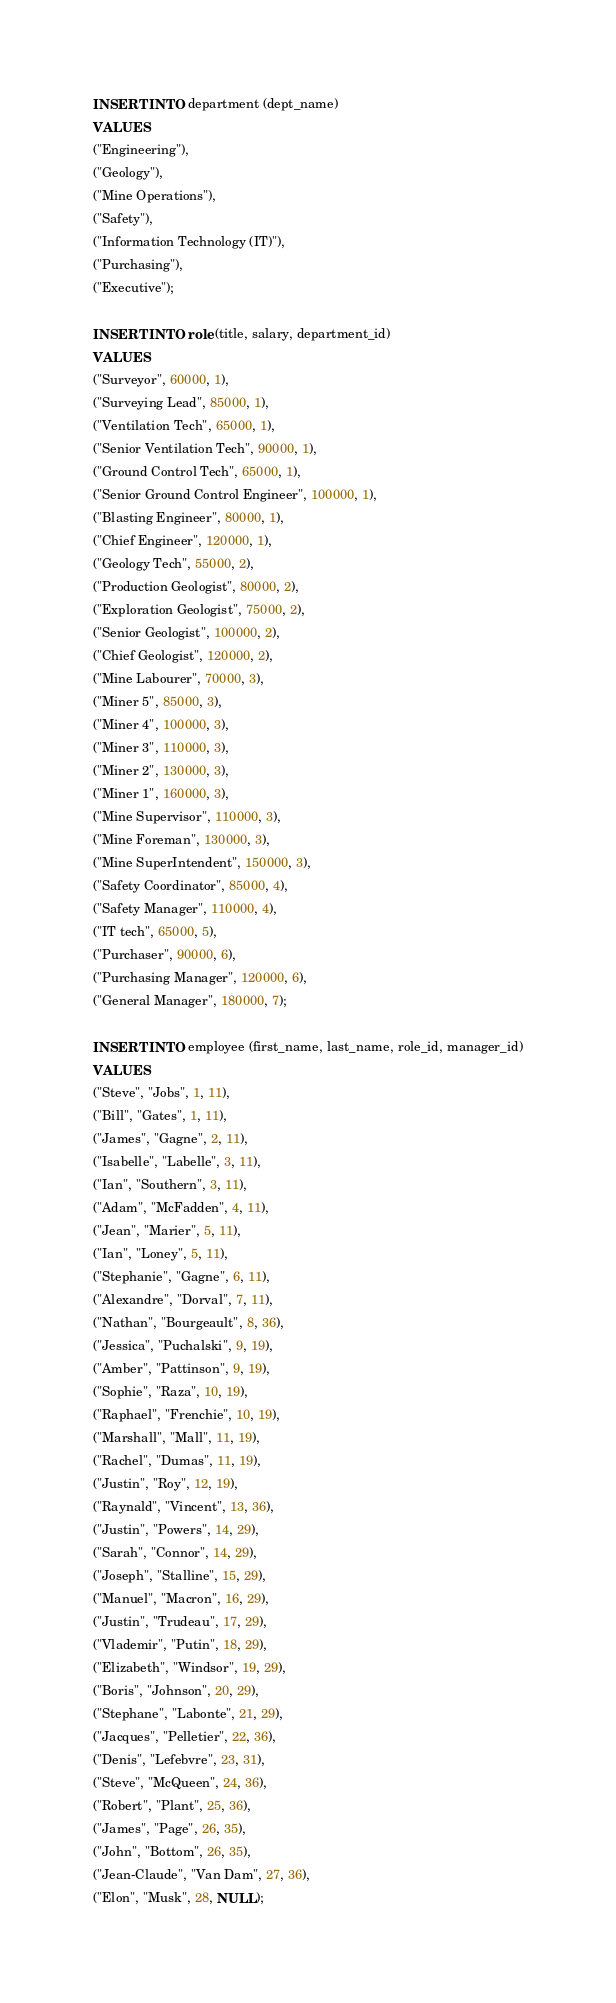<code> <loc_0><loc_0><loc_500><loc_500><_SQL_>INSERT INTO department (dept_name)
VALUES
("Engineering"),
("Geology"),
("Mine Operations"),
("Safety"),
("Information Technology (IT)"),
("Purchasing"),
("Executive");

INSERT INTO role (title, salary, department_id)
VALUES
("Surveyor", 60000, 1),
("Surveying Lead", 85000, 1),
("Ventilation Tech", 65000, 1),
("Senior Ventilation Tech", 90000, 1),
("Ground Control Tech", 65000, 1),
("Senior Ground Control Engineer", 100000, 1),
("Blasting Engineer", 80000, 1),
("Chief Engineer", 120000, 1),
("Geology Tech", 55000, 2),
("Production Geologist", 80000, 2),
("Exploration Geologist", 75000, 2),
("Senior Geologist", 100000, 2),
("Chief Geologist", 120000, 2),
("Mine Labourer", 70000, 3),
("Miner 5", 85000, 3),
("Miner 4", 100000, 3),
("Miner 3", 110000, 3),
("Miner 2", 130000, 3),
("Miner 1", 160000, 3),
("Mine Supervisor", 110000, 3),
("Mine Foreman", 130000, 3),
("Mine SuperIntendent", 150000, 3),
("Safety Coordinator", 85000, 4),
("Safety Manager", 110000, 4),
("IT tech", 65000, 5),
("Purchaser", 90000, 6),
("Purchasing Manager", 120000, 6),
("General Manager", 180000, 7);

INSERT INTO employee (first_name, last_name, role_id, manager_id)
VALUES
("Steve", "Jobs", 1, 11),
("Bill", "Gates", 1, 11),
("James", "Gagne", 2, 11),
("Isabelle", "Labelle", 3, 11),
("Ian", "Southern", 3, 11),
("Adam", "McFadden", 4, 11),
("Jean", "Marier", 5, 11),
("Ian", "Loney", 5, 11),
("Stephanie", "Gagne", 6, 11),
("Alexandre", "Dorval", 7, 11),
("Nathan", "Bourgeault", 8, 36),
("Jessica", "Puchalski", 9, 19),
("Amber", "Pattinson", 9, 19),
("Sophie", "Raza", 10, 19),
("Raphael", "Frenchie", 10, 19),
("Marshall", "Mall", 11, 19),
("Rachel", "Dumas", 11, 19),
("Justin", "Roy", 12, 19),
("Raynald", "Vincent", 13, 36),
("Justin", "Powers", 14, 29),
("Sarah", "Connor", 14, 29),
("Joseph", "Stalline", 15, 29),
("Manuel", "Macron", 16, 29),
("Justin", "Trudeau", 17, 29),
("Vlademir", "Putin", 18, 29),
("Elizabeth", "Windsor", 19, 29),
("Boris", "Johnson", 20, 29),
("Stephane", "Labonte", 21, 29),
("Jacques", "Pelletier", 22, 36),
("Denis", "Lefebvre", 23, 31),
("Steve", "McQueen", 24, 36),
("Robert", "Plant", 25, 36),
("James", "Page", 26, 35),
("John", "Bottom", 26, 35),
("Jean-Claude", "Van Dam", 27, 36),
("Elon", "Musk", 28, NULL);





</code> 